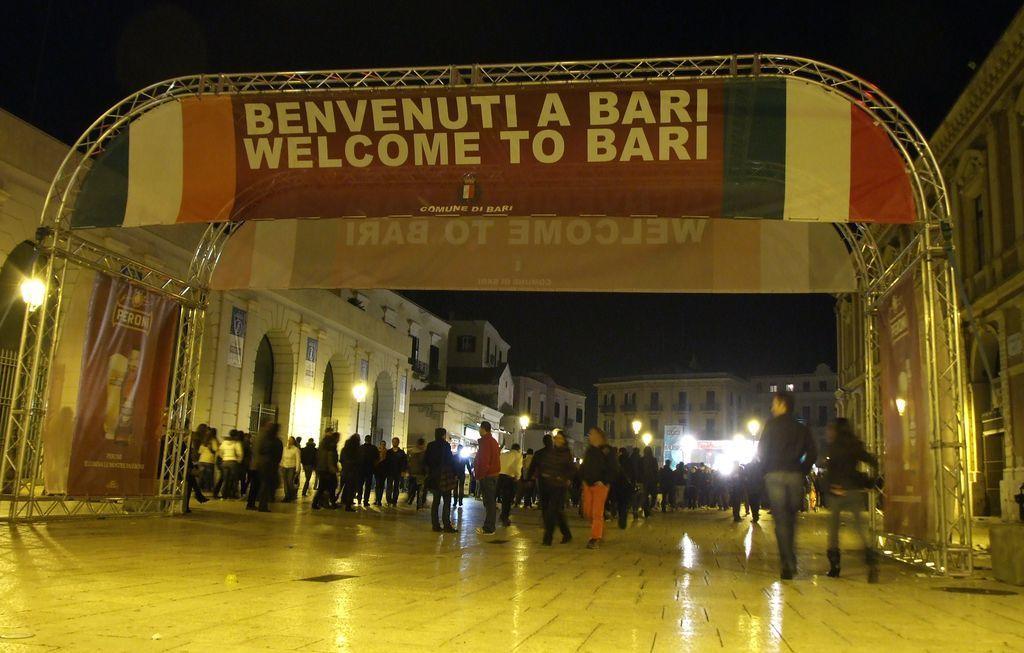Describe this image in one or two sentences. In this image there are group of persons standing and walking. On the top there is a banner with some text written on it. On the left side there is a light and there is a building. In the background there are buildings and there are light poles and there are persons. On the right side there is a building. 